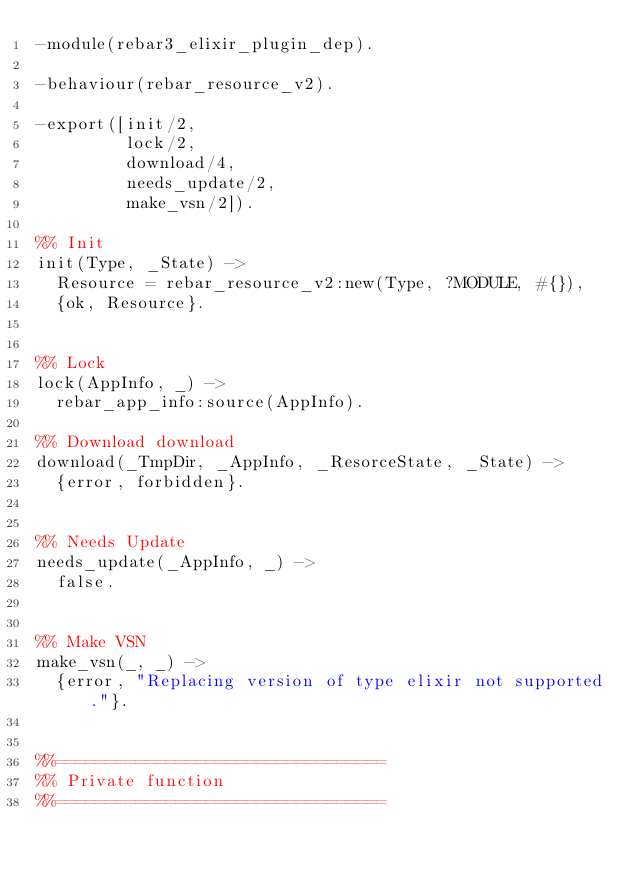<code> <loc_0><loc_0><loc_500><loc_500><_Erlang_>-module(rebar3_elixir_plugin_dep).

-behaviour(rebar_resource_v2).

-export([init/2,
         lock/2,
         download/4,
         needs_update/2,
         make_vsn/2]).

%% Init
init(Type, _State) ->
  Resource = rebar_resource_v2:new(Type, ?MODULE, #{}),
  {ok, Resource}.


%% Lock
lock(AppInfo, _) ->
  rebar_app_info:source(AppInfo).

%% Download download
download(_TmpDir, _AppInfo, _ResorceState, _State) ->
  {error, forbidden}.
  

%% Needs Update
needs_update(_AppInfo, _) ->
  false.


%% Make VSN
make_vsn(_, _) ->
  {error, "Replacing version of type elixir not supported."}.


%%=================================
%% Private function
%%=================================
</code> 